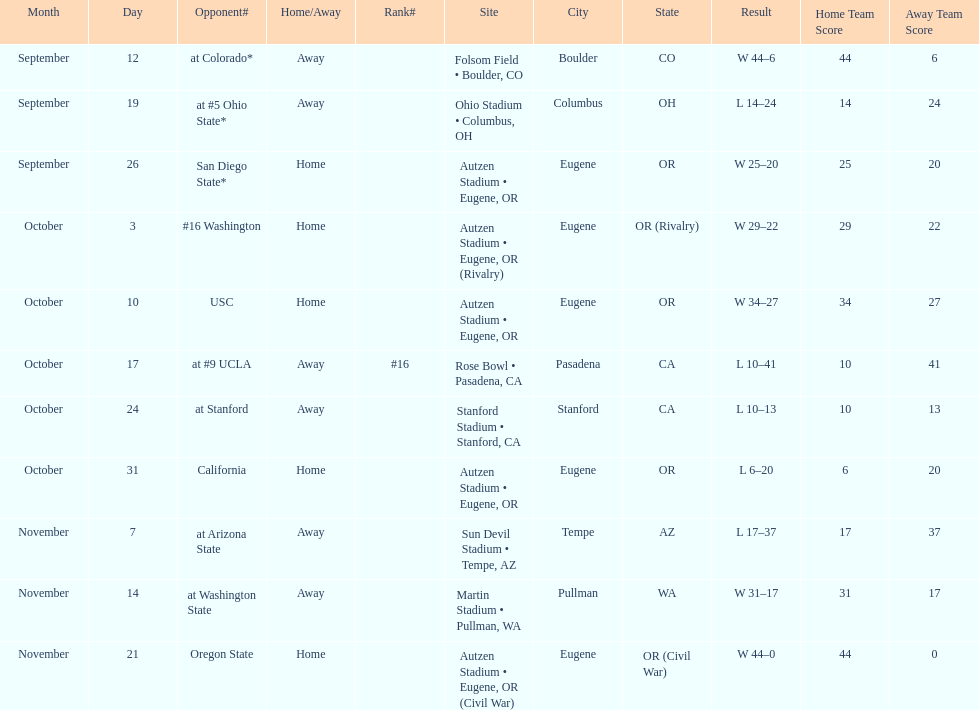Which bowl game did the university of oregon ducks football team play in during the 1987 season? Rose Bowl. 